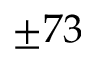Convert formula to latex. <formula><loc_0><loc_0><loc_500><loc_500>\pm 7 3</formula> 